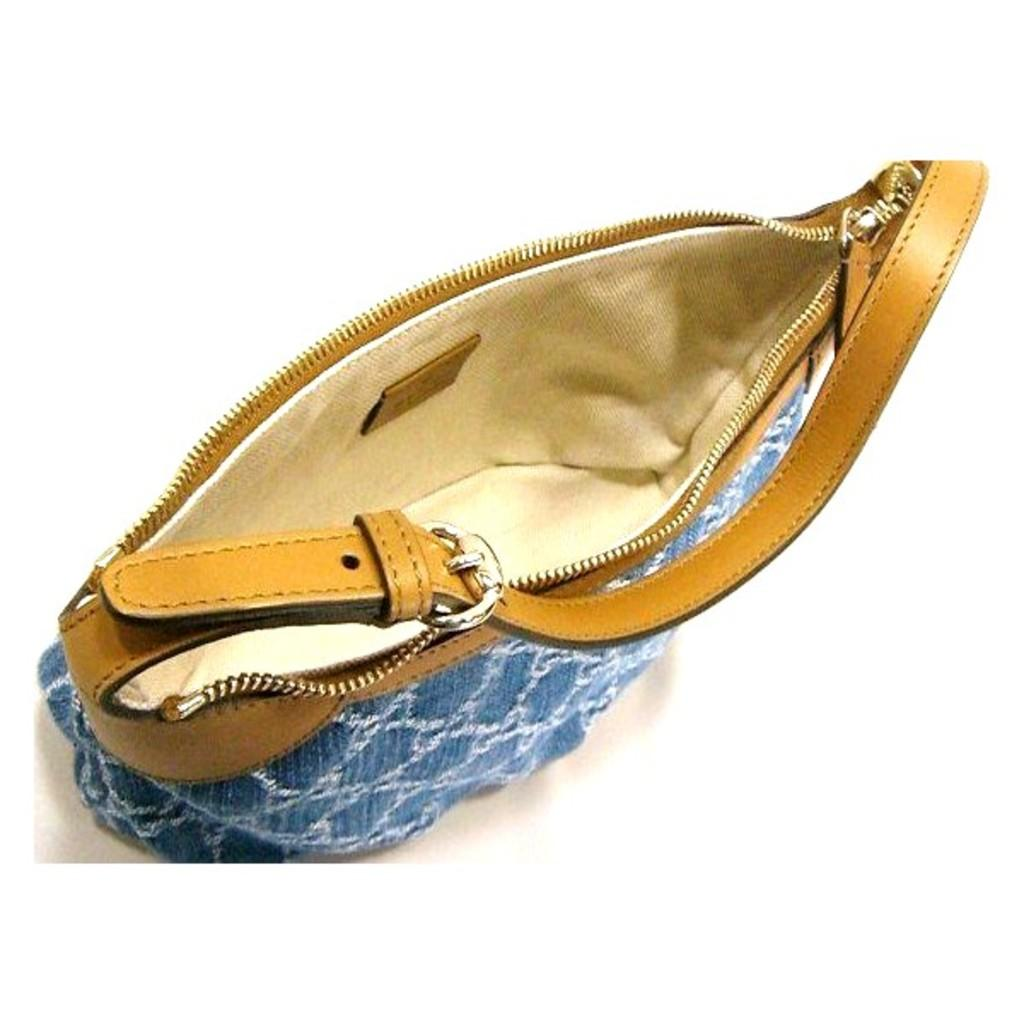What color is the handbag in the image? The handbag is blue in color. What can be seen inside the handbag? The image is an inner view of the handbag, so we can see its contents. What type of chess piece is located at the bottom of the handbag? There is no chess piece mentioned or visible in the image; it is an inner view of a blue handbag. 